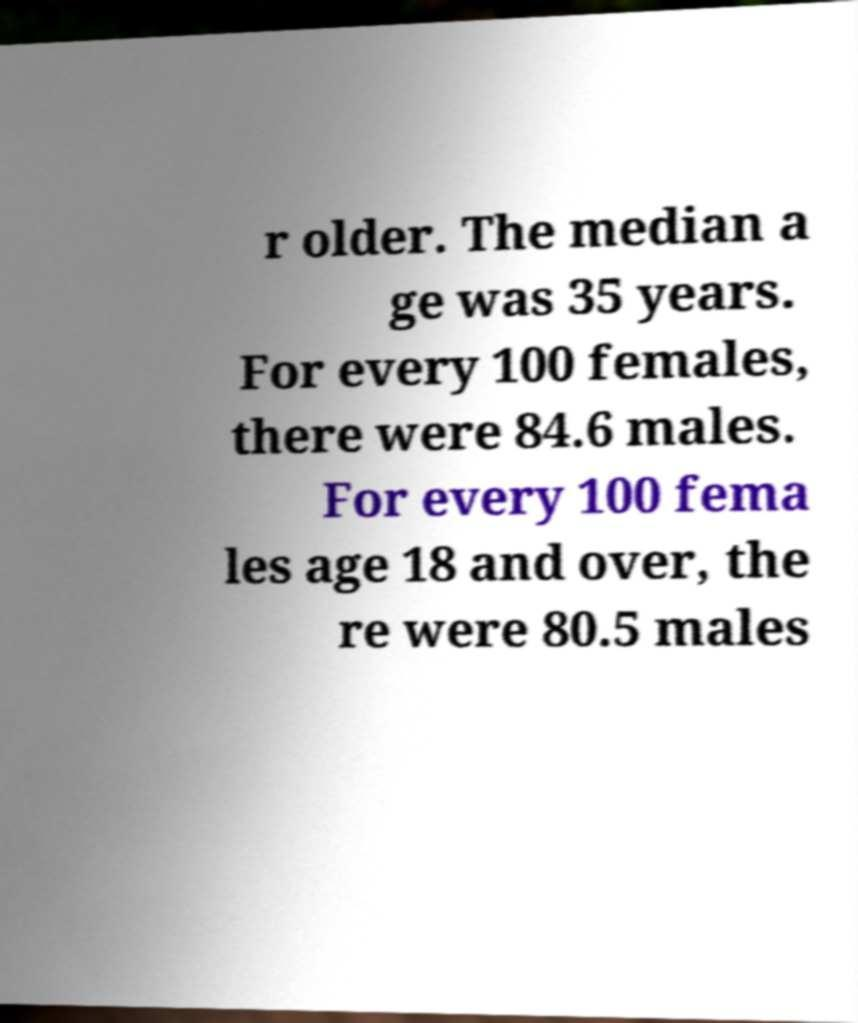Please identify and transcribe the text found in this image. r older. The median a ge was 35 years. For every 100 females, there were 84.6 males. For every 100 fema les age 18 and over, the re were 80.5 males 